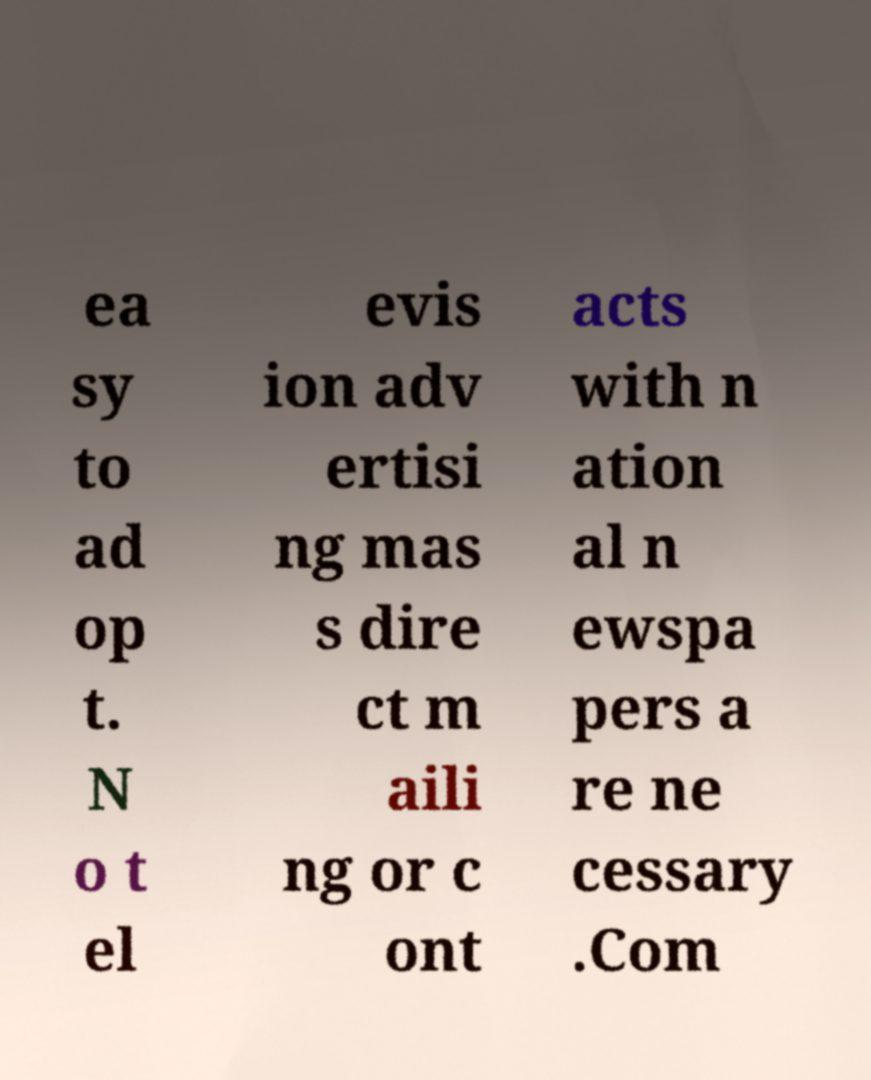Could you extract and type out the text from this image? ea sy to ad op t. N o t el evis ion adv ertisi ng mas s dire ct m aili ng or c ont acts with n ation al n ewspa pers a re ne cessary .Com 